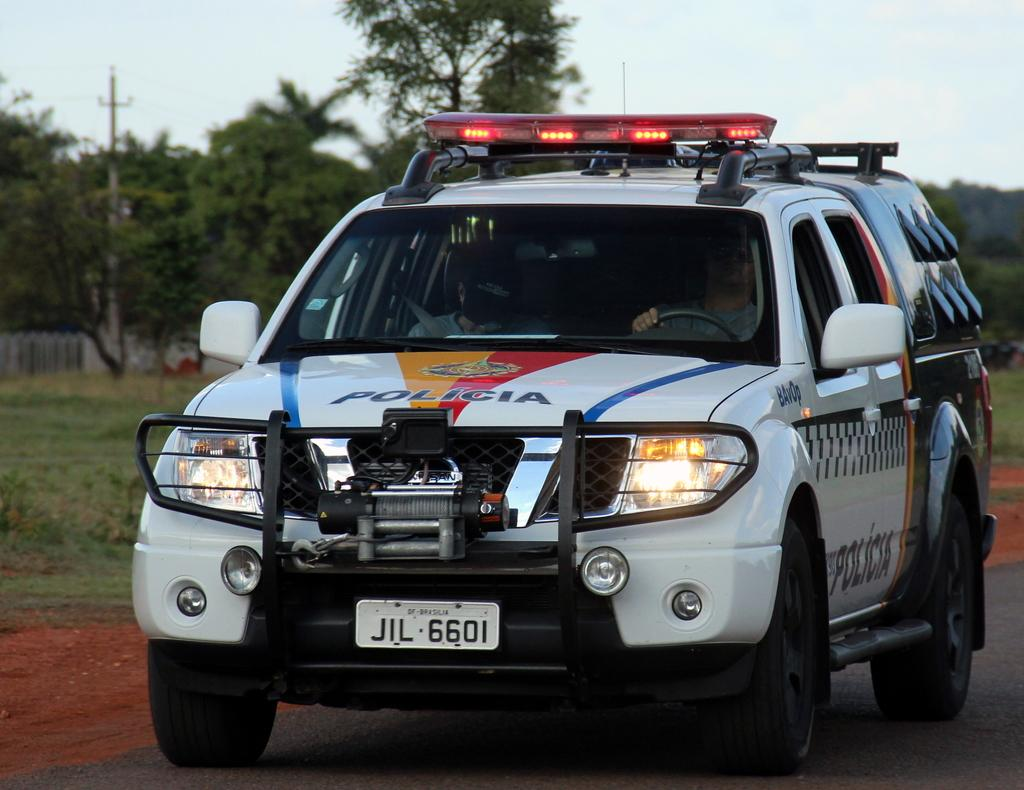What type of vehicle is in the image? There is a police van in the image. Where is the police van located? The police van is on the road. Who is inside the police van? There are two people sitting in the van. What can be seen in the background of the image? There are trees and a current pole in the background of the image. What type of zipper can be seen on the police van in the image? There is no zipper present on the police van in the image. Is there a volcano visible in the background of the image? No, there is no volcano present in the image; only trees and a current pole can be seen in the background. 